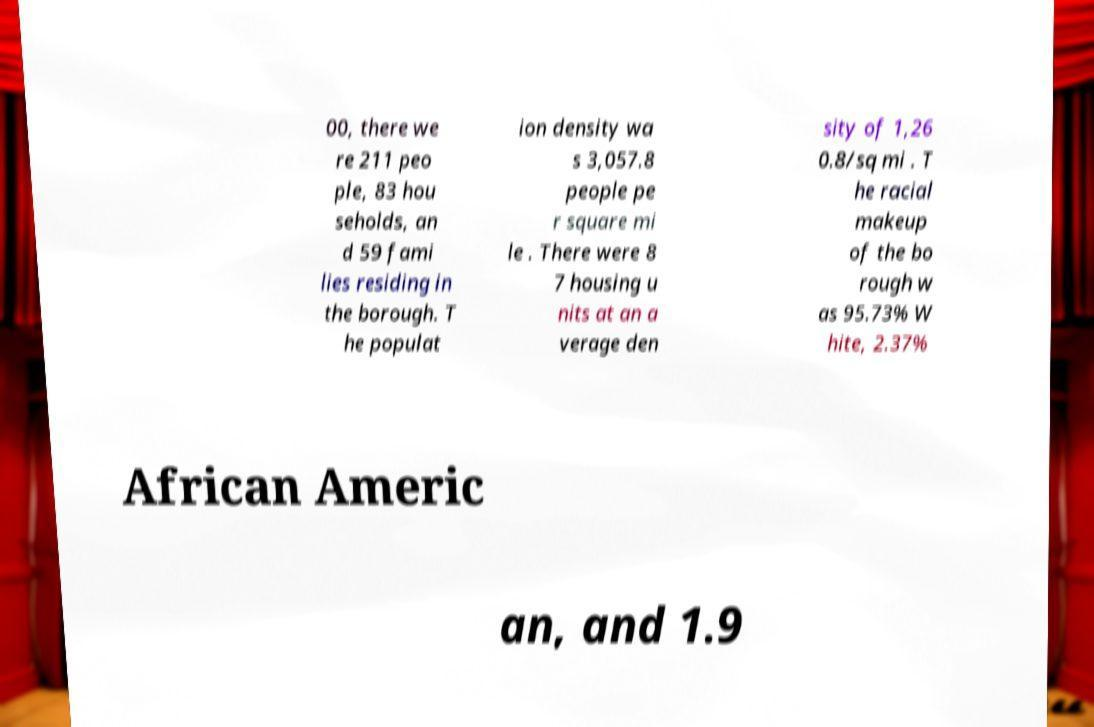There's text embedded in this image that I need extracted. Can you transcribe it verbatim? 00, there we re 211 peo ple, 83 hou seholds, an d 59 fami lies residing in the borough. T he populat ion density wa s 3,057.8 people pe r square mi le . There were 8 7 housing u nits at an a verage den sity of 1,26 0.8/sq mi . T he racial makeup of the bo rough w as 95.73% W hite, 2.37% African Americ an, and 1.9 